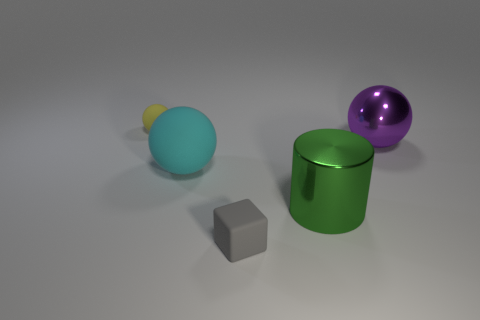What number of gray things are the same shape as the cyan object?
Give a very brief answer. 0. The large ball in front of the large sphere that is to the right of the gray matte block is made of what material?
Your answer should be compact. Rubber. What size is the ball on the right side of the tiny gray rubber thing?
Your answer should be very brief. Large. What number of gray things are either objects or spheres?
Ensure brevity in your answer.  1. Is there anything else that is made of the same material as the purple object?
Provide a succinct answer. Yes. What is the material of the purple object that is the same shape as the tiny yellow matte object?
Make the answer very short. Metal. Are there an equal number of purple metallic spheres behind the large purple sphere and small matte blocks?
Keep it short and to the point. No. What size is the matte object that is in front of the tiny yellow thing and behind the small rubber cube?
Offer a very short reply. Large. Are there any other things that have the same color as the small cube?
Your answer should be compact. No. How big is the matte thing in front of the green metallic thing that is behind the gray block?
Keep it short and to the point. Small. 